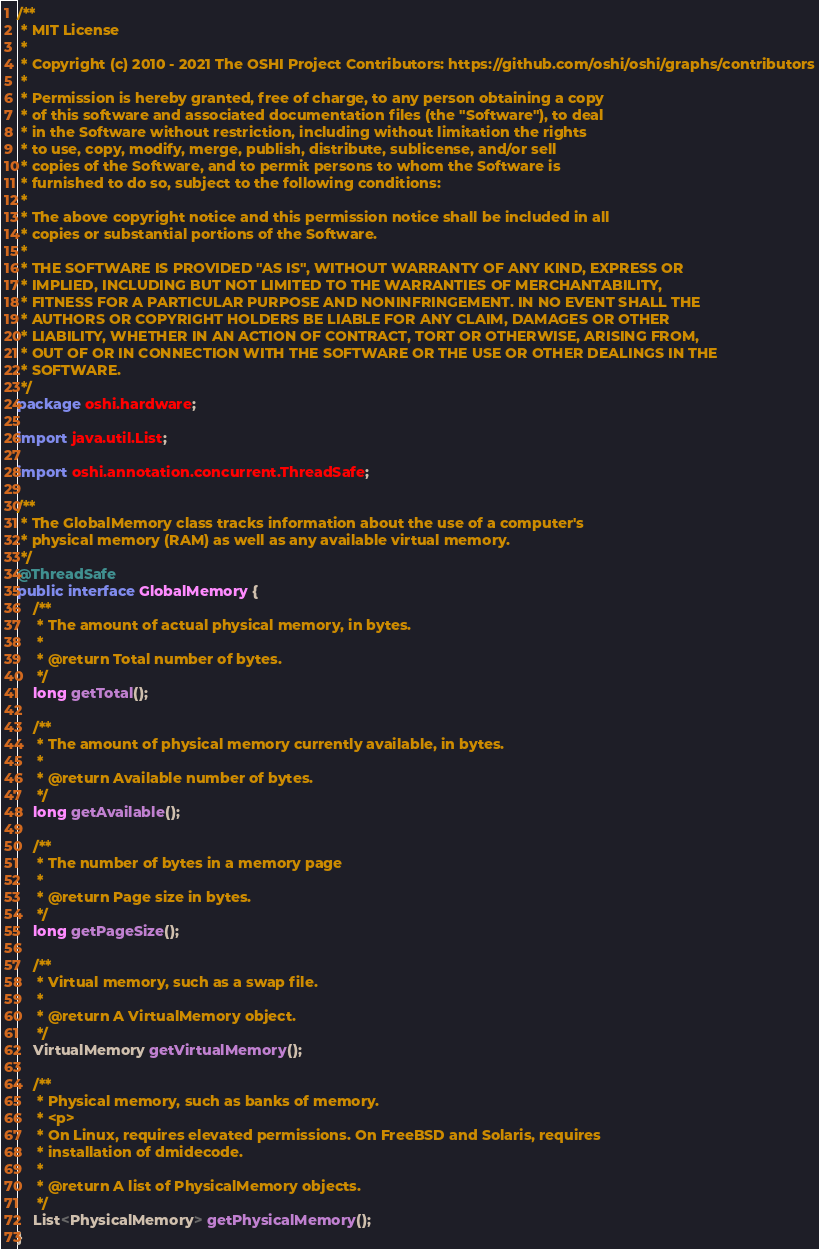<code> <loc_0><loc_0><loc_500><loc_500><_Java_>/**
 * MIT License
 *
 * Copyright (c) 2010 - 2021 The OSHI Project Contributors: https://github.com/oshi/oshi/graphs/contributors
 *
 * Permission is hereby granted, free of charge, to any person obtaining a copy
 * of this software and associated documentation files (the "Software"), to deal
 * in the Software without restriction, including without limitation the rights
 * to use, copy, modify, merge, publish, distribute, sublicense, and/or sell
 * copies of the Software, and to permit persons to whom the Software is
 * furnished to do so, subject to the following conditions:
 *
 * The above copyright notice and this permission notice shall be included in all
 * copies or substantial portions of the Software.
 *
 * THE SOFTWARE IS PROVIDED "AS IS", WITHOUT WARRANTY OF ANY KIND, EXPRESS OR
 * IMPLIED, INCLUDING BUT NOT LIMITED TO THE WARRANTIES OF MERCHANTABILITY,
 * FITNESS FOR A PARTICULAR PURPOSE AND NONINFRINGEMENT. IN NO EVENT SHALL THE
 * AUTHORS OR COPYRIGHT HOLDERS BE LIABLE FOR ANY CLAIM, DAMAGES OR OTHER
 * LIABILITY, WHETHER IN AN ACTION OF CONTRACT, TORT OR OTHERWISE, ARISING FROM,
 * OUT OF OR IN CONNECTION WITH THE SOFTWARE OR THE USE OR OTHER DEALINGS IN THE
 * SOFTWARE.
 */
package oshi.hardware;

import java.util.List;

import oshi.annotation.concurrent.ThreadSafe;

/**
 * The GlobalMemory class tracks information about the use of a computer's
 * physical memory (RAM) as well as any available virtual memory.
 */
@ThreadSafe
public interface GlobalMemory {
    /**
     * The amount of actual physical memory, in bytes.
     *
     * @return Total number of bytes.
     */
    long getTotal();

    /**
     * The amount of physical memory currently available, in bytes.
     *
     * @return Available number of bytes.
     */
    long getAvailable();

    /**
     * The number of bytes in a memory page
     *
     * @return Page size in bytes.
     */
    long getPageSize();

    /**
     * Virtual memory, such as a swap file.
     *
     * @return A VirtualMemory object.
     */
    VirtualMemory getVirtualMemory();

    /**
     * Physical memory, such as banks of memory.
     * <p>
     * On Linux, requires elevated permissions. On FreeBSD and Solaris, requires
     * installation of dmidecode.
     *
     * @return A list of PhysicalMemory objects.
     */
    List<PhysicalMemory> getPhysicalMemory();
}
</code> 